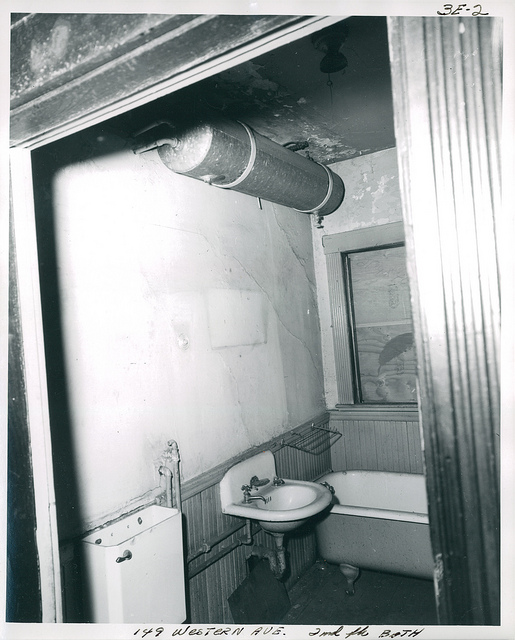How many sinks are there? 1 